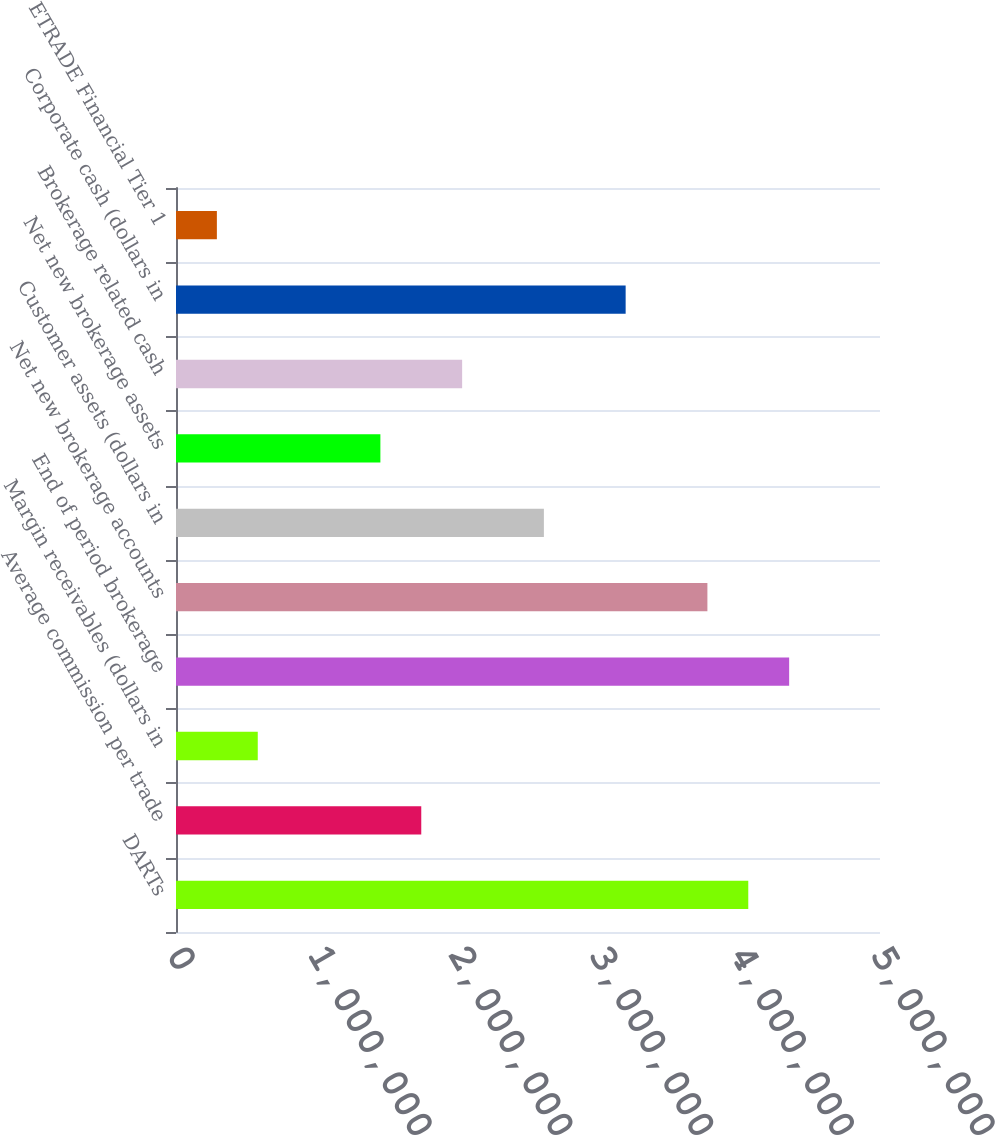Convert chart. <chart><loc_0><loc_0><loc_500><loc_500><bar_chart><fcel>DARTs<fcel>Average commission per trade<fcel>Margin receivables (dollars in<fcel>End of period brokerage<fcel>Net new brokerage accounts<fcel>Customer assets (dollars in<fcel>Net new brokerage assets<fcel>Brokerage related cash<fcel>Corporate cash (dollars in<fcel>ETRADE Financial Tier 1<nl><fcel>4.06447e+06<fcel>1.74192e+06<fcel>580640<fcel>4.35479e+06<fcel>3.77415e+06<fcel>2.61287e+06<fcel>1.4516e+06<fcel>2.03223e+06<fcel>3.19351e+06<fcel>290321<nl></chart> 